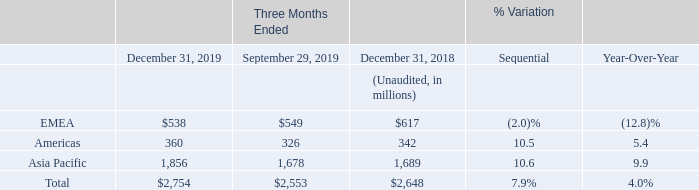By region of shipment, in the 2019 fourth quarter, Asia Pacific revenues grew sequentially by 10.6%, principally in Imaging, Analog and Microcontrollers, Americas was up by 10.5%, mainly driven by Digital and Power Discrete, and EMEA decreased by 2.0%.
On a year-over-year basis, revenues grew 9.9% in Asia Pacific, mainly due to Analog, Microcontrollers and Imaging. In Americas, revenues grew 5.4%, mainly driven by Digital and Power Discrete, while it decreased by 12.8% in EMEA, mainly due to lower sales in Automotive, Power Discrete and  analog.
What caused the increase in Asia Pacific revenues in fourth quarter of 2019? Imaging, analog and microcontrollers, americas was up by 10.5%, mainly driven by digital and power discrete, and emea decreased by 2.0%. What was the year-over-year increase in revenue for Asia? 9.9%. What caused the year-over-year increase in Revenue for Asia? Mainly due to analog, microcontrollers and imaging. What is the increase / (decrease) in the EMEA revenue from 2018 to 2019?
Answer scale should be: million. 538 - 617
Answer: -79. What is the average Americas revenue in 2019 and 2018?
Answer scale should be: million. (360 + 342) / 2
Answer: 351. What is the increase / (decrease) in the total revenue from 2018 to 2019?
Answer scale should be: million. 2,754 - 2,648
Answer: 106. 